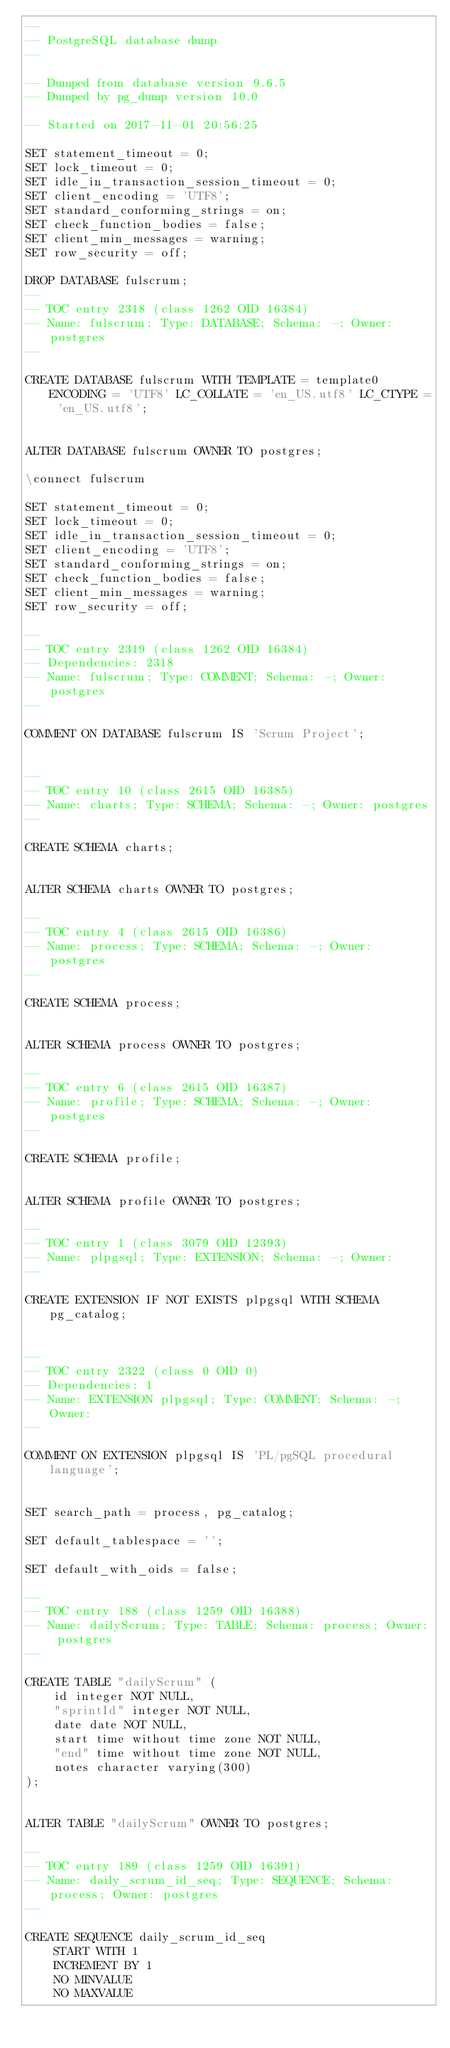Convert code to text. <code><loc_0><loc_0><loc_500><loc_500><_SQL_>--
-- PostgreSQL database dump
--

-- Dumped from database version 9.6.5
-- Dumped by pg_dump version 10.0

-- Started on 2017-11-01 20:56:25

SET statement_timeout = 0;
SET lock_timeout = 0;
SET idle_in_transaction_session_timeout = 0;
SET client_encoding = 'UTF8';
SET standard_conforming_strings = on;
SET check_function_bodies = false;
SET client_min_messages = warning;
SET row_security = off;

DROP DATABASE fulscrum;
--
-- TOC entry 2318 (class 1262 OID 16384)
-- Name: fulscrum; Type: DATABASE; Schema: -; Owner: postgres
--

CREATE DATABASE fulscrum WITH TEMPLATE = template0 ENCODING = 'UTF8' LC_COLLATE = 'en_US.utf8' LC_CTYPE = 'en_US.utf8';


ALTER DATABASE fulscrum OWNER TO postgres;

\connect fulscrum

SET statement_timeout = 0;
SET lock_timeout = 0;
SET idle_in_transaction_session_timeout = 0;
SET client_encoding = 'UTF8';
SET standard_conforming_strings = on;
SET check_function_bodies = false;
SET client_min_messages = warning;
SET row_security = off;

--
-- TOC entry 2319 (class 1262 OID 16384)
-- Dependencies: 2318
-- Name: fulscrum; Type: COMMENT; Schema: -; Owner: postgres
--

COMMENT ON DATABASE fulscrum IS 'Scrum Project';


--
-- TOC entry 10 (class 2615 OID 16385)
-- Name: charts; Type: SCHEMA; Schema: -; Owner: postgres
--

CREATE SCHEMA charts;


ALTER SCHEMA charts OWNER TO postgres;

--
-- TOC entry 4 (class 2615 OID 16386)
-- Name: process; Type: SCHEMA; Schema: -; Owner: postgres
--

CREATE SCHEMA process;


ALTER SCHEMA process OWNER TO postgres;

--
-- TOC entry 6 (class 2615 OID 16387)
-- Name: profile; Type: SCHEMA; Schema: -; Owner: postgres
--

CREATE SCHEMA profile;


ALTER SCHEMA profile OWNER TO postgres;

--
-- TOC entry 1 (class 3079 OID 12393)
-- Name: plpgsql; Type: EXTENSION; Schema: -; Owner: 
--

CREATE EXTENSION IF NOT EXISTS plpgsql WITH SCHEMA pg_catalog;


--
-- TOC entry 2322 (class 0 OID 0)
-- Dependencies: 1
-- Name: EXTENSION plpgsql; Type: COMMENT; Schema: -; Owner: 
--

COMMENT ON EXTENSION plpgsql IS 'PL/pgSQL procedural language';


SET search_path = process, pg_catalog;

SET default_tablespace = '';

SET default_with_oids = false;

--
-- TOC entry 188 (class 1259 OID 16388)
-- Name: dailyScrum; Type: TABLE; Schema: process; Owner: postgres
--

CREATE TABLE "dailyScrum" (
    id integer NOT NULL,
    "sprintId" integer NOT NULL,
    date date NOT NULL,
    start time without time zone NOT NULL,
    "end" time without time zone NOT NULL,
    notes character varying(300)
);


ALTER TABLE "dailyScrum" OWNER TO postgres;

--
-- TOC entry 189 (class 1259 OID 16391)
-- Name: daily_scrum_id_seq; Type: SEQUENCE; Schema: process; Owner: postgres
--

CREATE SEQUENCE daily_scrum_id_seq
    START WITH 1
    INCREMENT BY 1
    NO MINVALUE
    NO MAXVALUE</code> 